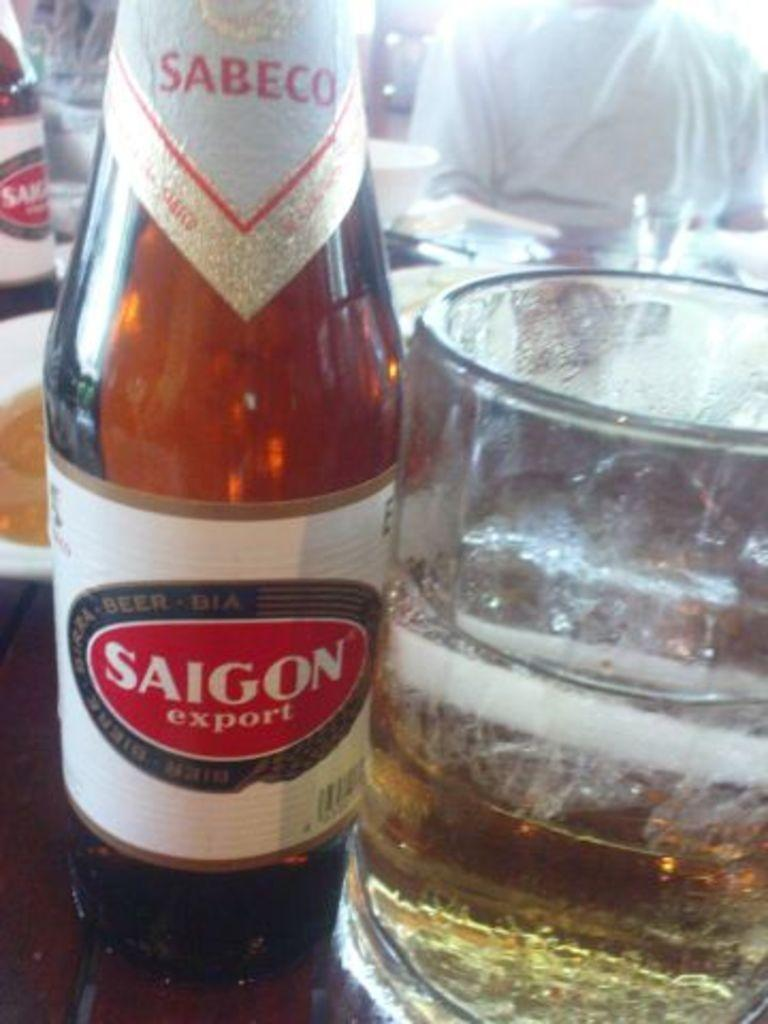<image>
Write a terse but informative summary of the picture. A glass of beer next to a bottle reading Saigon Export. 